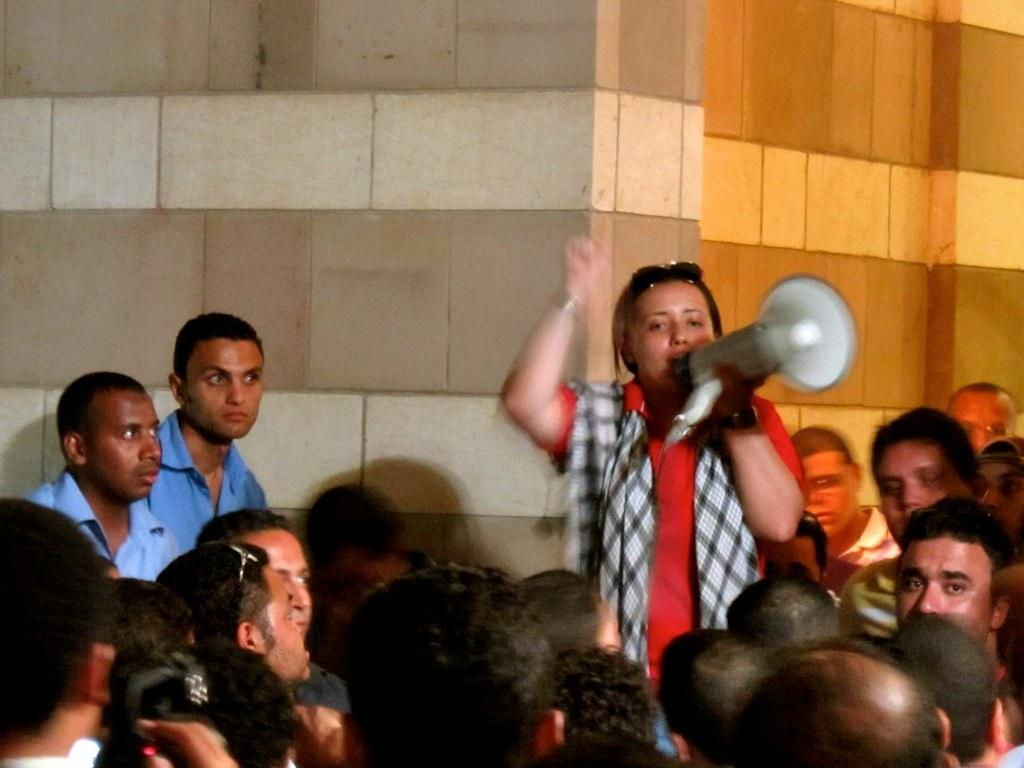What can be seen in the front of the image? There are people in the front of the image. What is one person doing with their hands? One person is holding a speaker. What is visible in the background of the image? There is a wall in the background of the image. What type of cloth is draped over the speaker in the image? There is no cloth draped over the speaker in the image. What songs are being played from the speaker in the image? The image does not provide information about the songs being played from the speaker. 